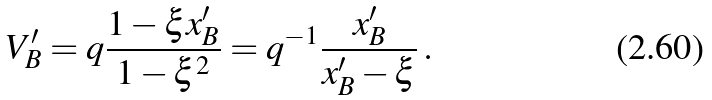<formula> <loc_0><loc_0><loc_500><loc_500>V ^ { \prime } _ { B } = q \frac { 1 - \xi x ^ { \prime } _ { B } } { 1 - \xi ^ { 2 } } = q ^ { - 1 } \frac { x ^ { \prime } _ { B } } { x ^ { \prime } _ { B } - \xi } \, .</formula> 